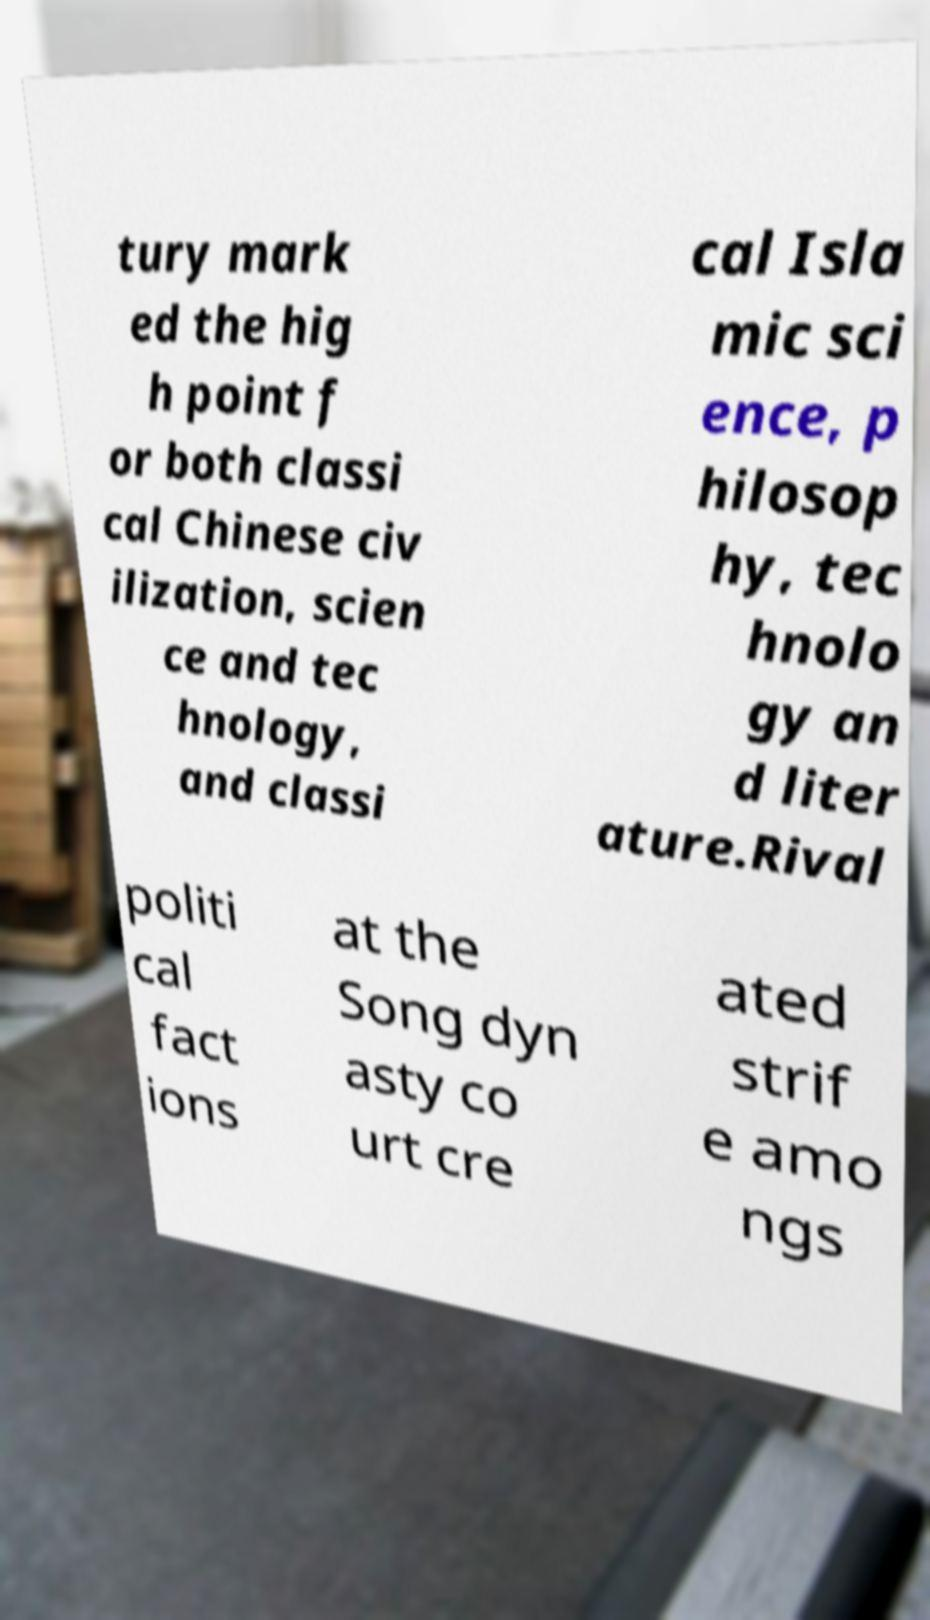Could you extract and type out the text from this image? tury mark ed the hig h point f or both classi cal Chinese civ ilization, scien ce and tec hnology, and classi cal Isla mic sci ence, p hilosop hy, tec hnolo gy an d liter ature.Rival politi cal fact ions at the Song dyn asty co urt cre ated strif e amo ngs 